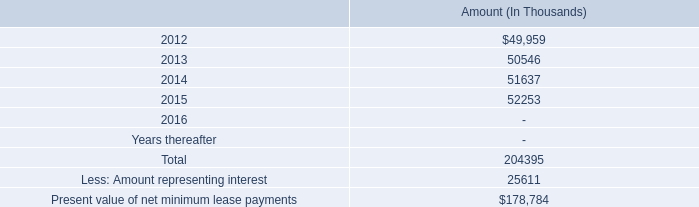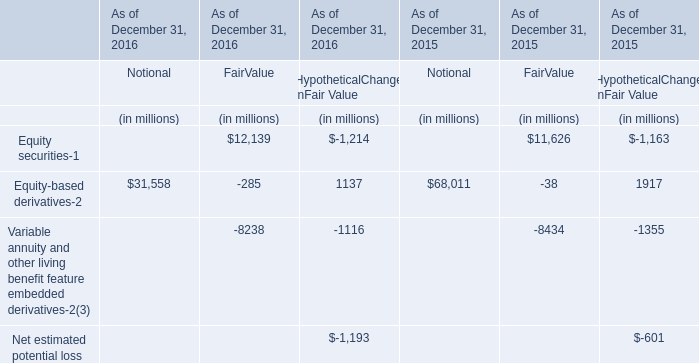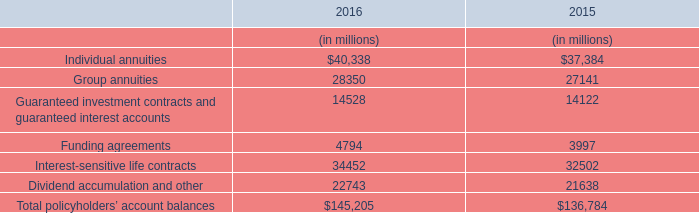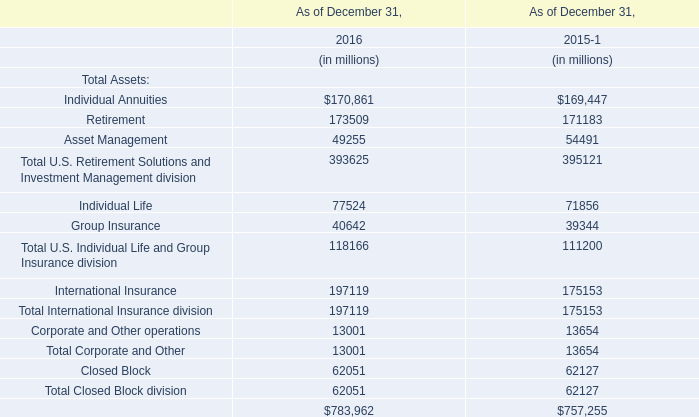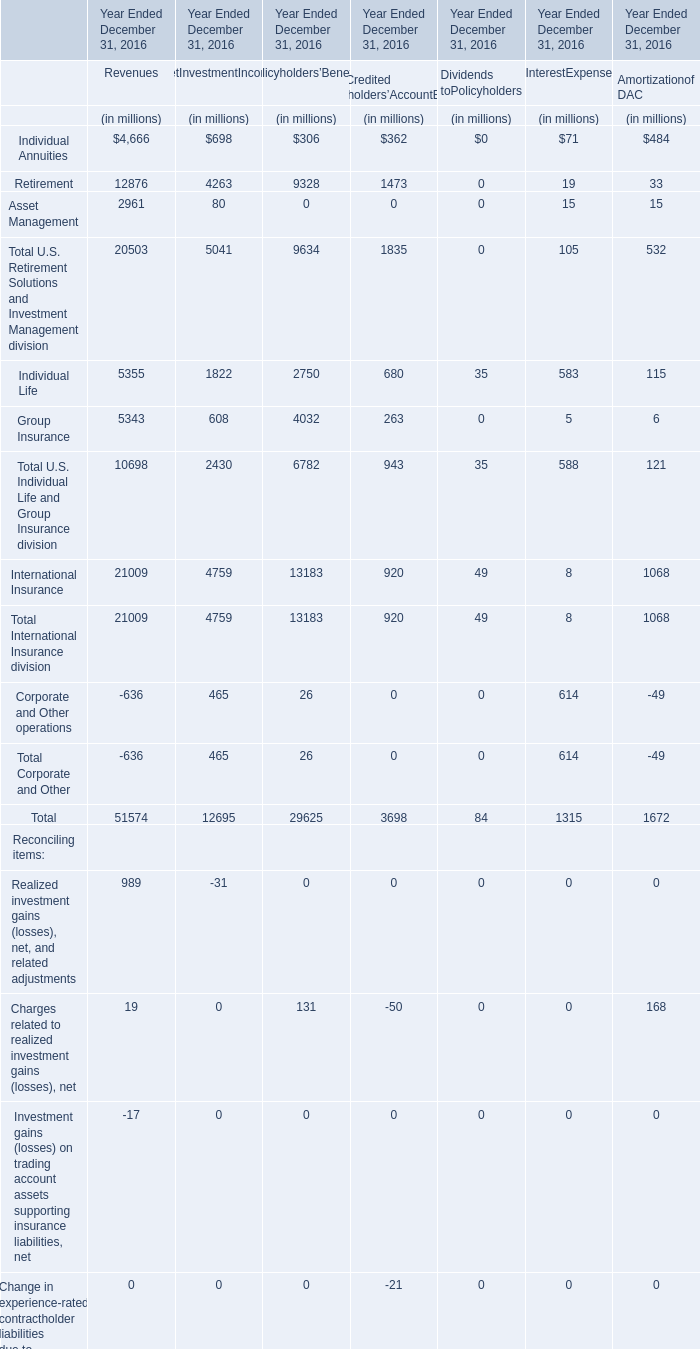In which section is Total U.S. Retirement Solutions and Investment Management division greater than 20000?? 
Answer: Revenues. 